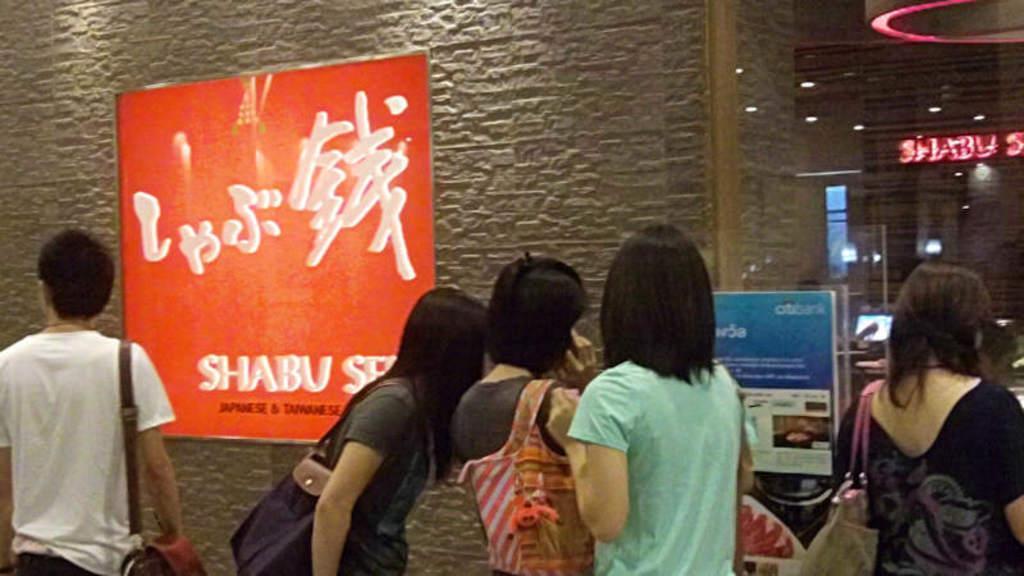Could you give a brief overview of what you see in this image? There are many people. Some are wearing bags. In the back there is a wall with a poster. On that something is written. Also there is a glass wall. Near to that there is a poster. 